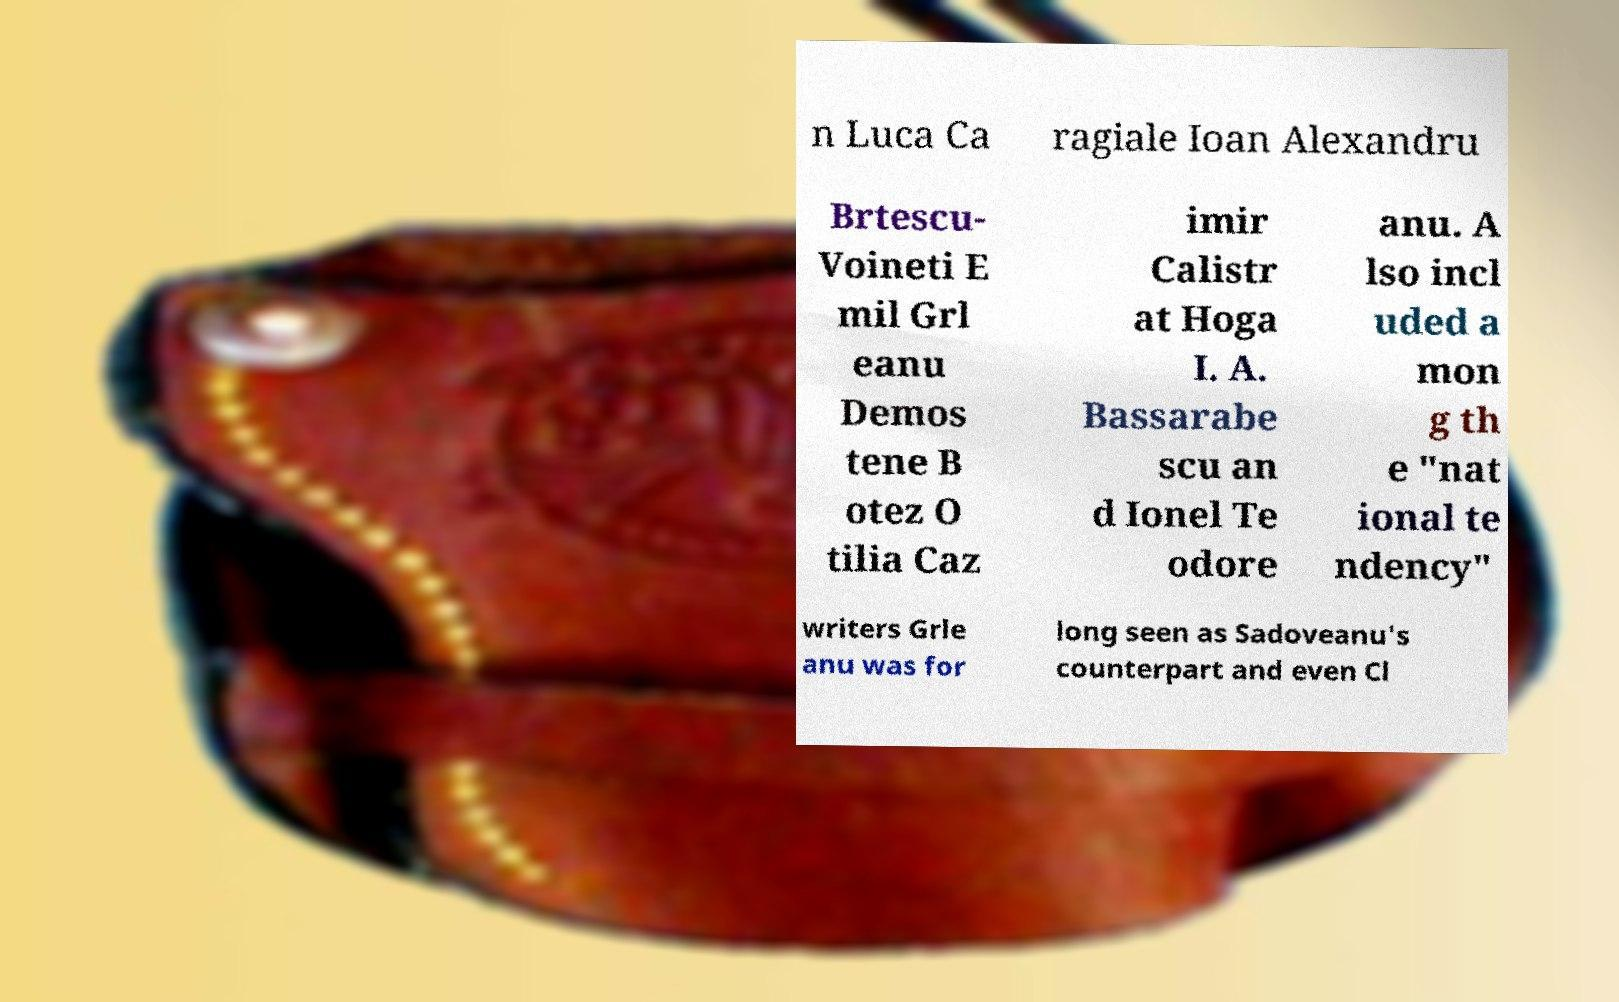Please identify and transcribe the text found in this image. n Luca Ca ragiale Ioan Alexandru Brtescu- Voineti E mil Grl eanu Demos tene B otez O tilia Caz imir Calistr at Hoga I. A. Bassarabe scu an d Ionel Te odore anu. A lso incl uded a mon g th e "nat ional te ndency" writers Grle anu was for long seen as Sadoveanu's counterpart and even Cl 